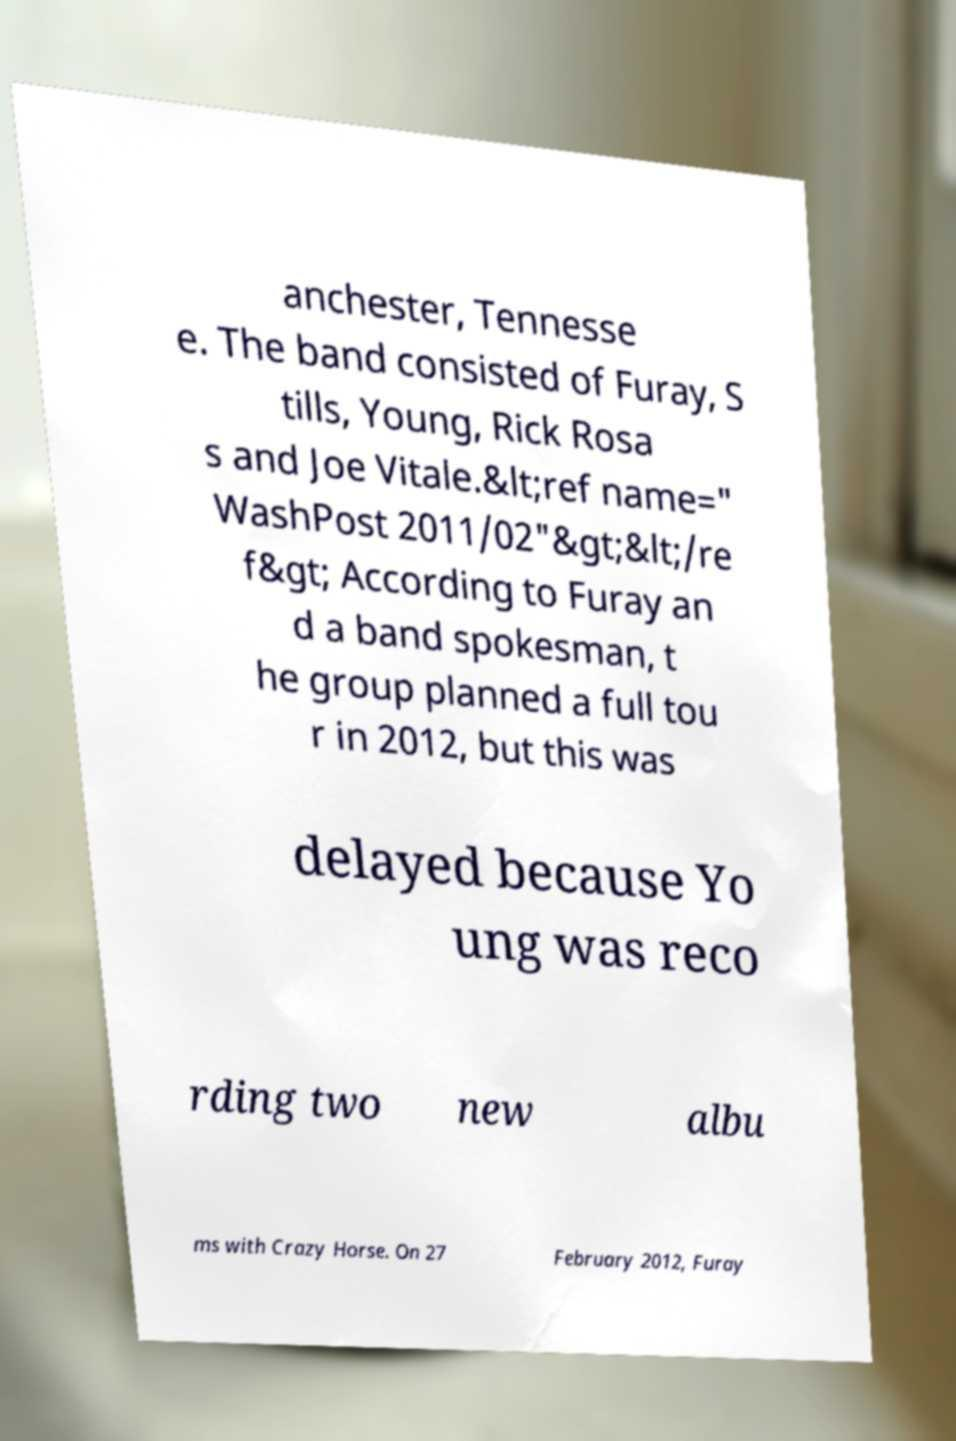Could you extract and type out the text from this image? anchester, Tennesse e. The band consisted of Furay, S tills, Young, Rick Rosa s and Joe Vitale.&lt;ref name=" WashPost 2011/02"&gt;&lt;/re f&gt; According to Furay an d a band spokesman, t he group planned a full tou r in 2012, but this was delayed because Yo ung was reco rding two new albu ms with Crazy Horse. On 27 February 2012, Furay 